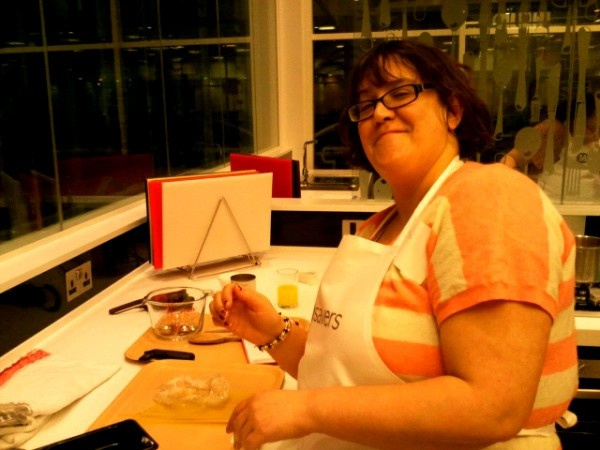Describe the objects in this image and their specific colors. I can see people in black, red, orange, gold, and maroon tones, dining table in black, orange, khaki, and gold tones, book in black, orange, and red tones, oven in black, maroon, orange, and khaki tones, and cup in black, orange, and red tones in this image. 